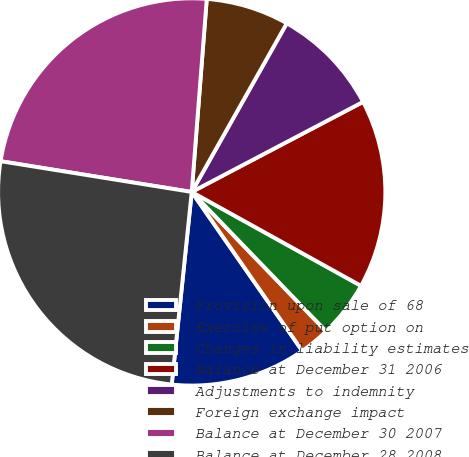Convert chart. <chart><loc_0><loc_0><loc_500><loc_500><pie_chart><fcel>Provision upon sale of 68<fcel>Exercise of put option on<fcel>Changes in liability estimates<fcel>Balance at December 31 2006<fcel>Adjustments to indemnity<fcel>Foreign exchange impact<fcel>Balance at December 30 2007<fcel>Balance at December 28 2008<nl><fcel>11.32%<fcel>2.54%<fcel>4.73%<fcel>15.76%<fcel>9.13%<fcel>6.93%<fcel>23.7%<fcel>25.89%<nl></chart> 